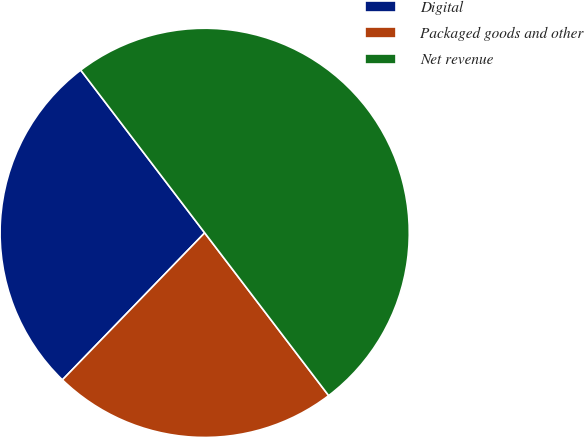Convert chart to OTSL. <chart><loc_0><loc_0><loc_500><loc_500><pie_chart><fcel>Digital<fcel>Packaged goods and other<fcel>Net revenue<nl><fcel>27.4%<fcel>22.6%<fcel>50.0%<nl></chart> 